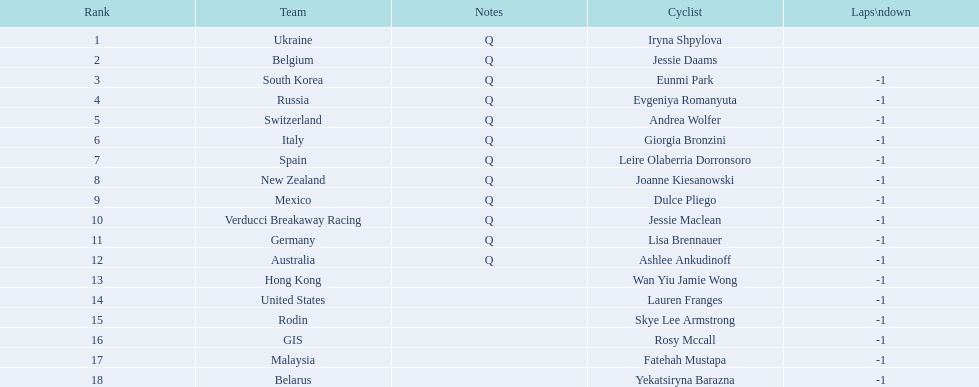Who competed in the race? Iryna Shpylova, Jessie Daams, Eunmi Park, Evgeniya Romanyuta, Andrea Wolfer, Giorgia Bronzini, Leire Olaberria Dorronsoro, Joanne Kiesanowski, Dulce Pliego, Jessie Maclean, Lisa Brennauer, Ashlee Ankudinoff, Wan Yiu Jamie Wong, Lauren Franges, Skye Lee Armstrong, Rosy Mccall, Fatehah Mustapa, Yekatsiryna Barazna. Who ranked highest in the race? Iryna Shpylova. 